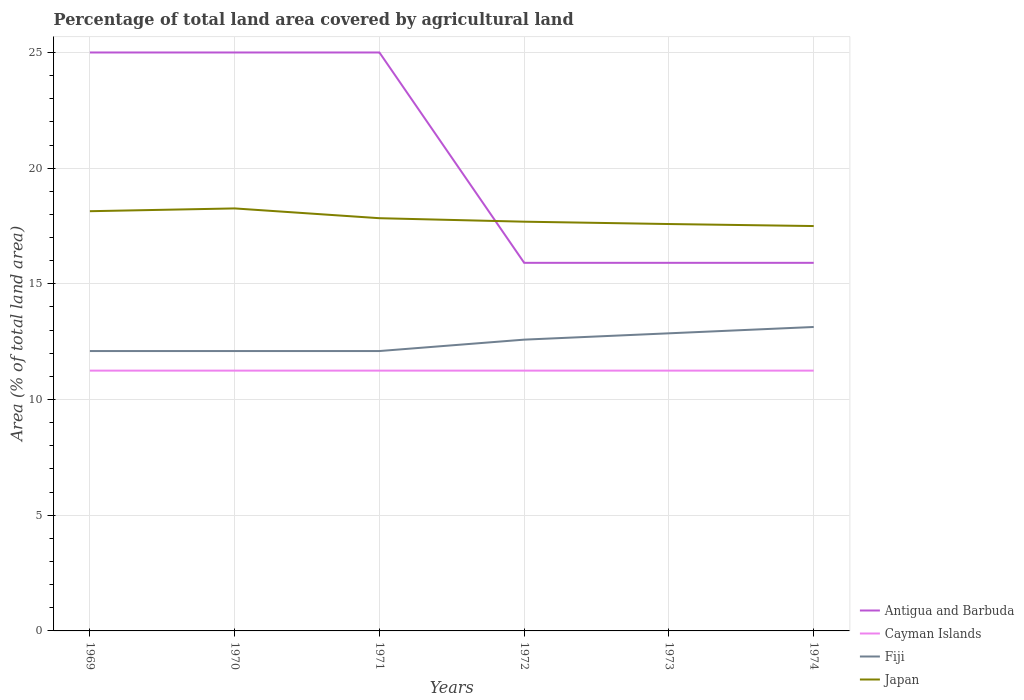Across all years, what is the maximum percentage of agricultural land in Japan?
Your answer should be compact. 17.5. What is the difference between the highest and the second highest percentage of agricultural land in Fiji?
Make the answer very short. 1.04. How many lines are there?
Provide a succinct answer. 4. How many years are there in the graph?
Your answer should be compact. 6. What is the difference between two consecutive major ticks on the Y-axis?
Make the answer very short. 5. Are the values on the major ticks of Y-axis written in scientific E-notation?
Make the answer very short. No. Where does the legend appear in the graph?
Make the answer very short. Bottom right. How are the legend labels stacked?
Keep it short and to the point. Vertical. What is the title of the graph?
Provide a succinct answer. Percentage of total land area covered by agricultural land. What is the label or title of the X-axis?
Your answer should be compact. Years. What is the label or title of the Y-axis?
Keep it short and to the point. Area (% of total land area). What is the Area (% of total land area) of Antigua and Barbuda in 1969?
Provide a succinct answer. 25. What is the Area (% of total land area) in Cayman Islands in 1969?
Make the answer very short. 11.25. What is the Area (% of total land area) in Fiji in 1969?
Your answer should be very brief. 12.1. What is the Area (% of total land area) of Japan in 1969?
Give a very brief answer. 18.14. What is the Area (% of total land area) in Antigua and Barbuda in 1970?
Your response must be concise. 25. What is the Area (% of total land area) in Cayman Islands in 1970?
Your answer should be compact. 11.25. What is the Area (% of total land area) in Fiji in 1970?
Your answer should be very brief. 12.1. What is the Area (% of total land area) in Japan in 1970?
Provide a succinct answer. 18.26. What is the Area (% of total land area) in Cayman Islands in 1971?
Offer a very short reply. 11.25. What is the Area (% of total land area) of Fiji in 1971?
Give a very brief answer. 12.1. What is the Area (% of total land area) of Japan in 1971?
Your answer should be compact. 17.84. What is the Area (% of total land area) of Antigua and Barbuda in 1972?
Give a very brief answer. 15.91. What is the Area (% of total land area) of Cayman Islands in 1972?
Keep it short and to the point. 11.25. What is the Area (% of total land area) in Fiji in 1972?
Provide a short and direct response. 12.59. What is the Area (% of total land area) of Japan in 1972?
Make the answer very short. 17.69. What is the Area (% of total land area) in Antigua and Barbuda in 1973?
Offer a terse response. 15.91. What is the Area (% of total land area) of Cayman Islands in 1973?
Offer a terse response. 11.25. What is the Area (% of total land area) in Fiji in 1973?
Your answer should be compact. 12.86. What is the Area (% of total land area) of Japan in 1973?
Offer a terse response. 17.59. What is the Area (% of total land area) in Antigua and Barbuda in 1974?
Give a very brief answer. 15.91. What is the Area (% of total land area) of Cayman Islands in 1974?
Offer a very short reply. 11.25. What is the Area (% of total land area) of Fiji in 1974?
Provide a succinct answer. 13.14. What is the Area (% of total land area) of Japan in 1974?
Your response must be concise. 17.5. Across all years, what is the maximum Area (% of total land area) of Antigua and Barbuda?
Ensure brevity in your answer.  25. Across all years, what is the maximum Area (% of total land area) in Cayman Islands?
Give a very brief answer. 11.25. Across all years, what is the maximum Area (% of total land area) of Fiji?
Provide a short and direct response. 13.14. Across all years, what is the maximum Area (% of total land area) of Japan?
Give a very brief answer. 18.26. Across all years, what is the minimum Area (% of total land area) of Antigua and Barbuda?
Offer a very short reply. 15.91. Across all years, what is the minimum Area (% of total land area) in Cayman Islands?
Provide a succinct answer. 11.25. Across all years, what is the minimum Area (% of total land area) in Fiji?
Give a very brief answer. 12.1. Across all years, what is the minimum Area (% of total land area) in Japan?
Your response must be concise. 17.5. What is the total Area (% of total land area) of Antigua and Barbuda in the graph?
Provide a short and direct response. 122.73. What is the total Area (% of total land area) in Cayman Islands in the graph?
Your response must be concise. 67.5. What is the total Area (% of total land area) in Fiji in the graph?
Offer a very short reply. 74.88. What is the total Area (% of total land area) in Japan in the graph?
Provide a succinct answer. 107.01. What is the difference between the Area (% of total land area) of Antigua and Barbuda in 1969 and that in 1970?
Keep it short and to the point. 0. What is the difference between the Area (% of total land area) of Cayman Islands in 1969 and that in 1970?
Your answer should be very brief. 0. What is the difference between the Area (% of total land area) in Fiji in 1969 and that in 1970?
Ensure brevity in your answer.  0. What is the difference between the Area (% of total land area) in Japan in 1969 and that in 1970?
Your answer should be very brief. -0.12. What is the difference between the Area (% of total land area) of Antigua and Barbuda in 1969 and that in 1971?
Keep it short and to the point. 0. What is the difference between the Area (% of total land area) in Cayman Islands in 1969 and that in 1971?
Your answer should be very brief. 0. What is the difference between the Area (% of total land area) in Fiji in 1969 and that in 1971?
Ensure brevity in your answer.  0. What is the difference between the Area (% of total land area) of Japan in 1969 and that in 1971?
Provide a succinct answer. 0.3. What is the difference between the Area (% of total land area) of Antigua and Barbuda in 1969 and that in 1972?
Your answer should be compact. 9.09. What is the difference between the Area (% of total land area) in Fiji in 1969 and that in 1972?
Your answer should be compact. -0.49. What is the difference between the Area (% of total land area) in Japan in 1969 and that in 1972?
Provide a succinct answer. 0.45. What is the difference between the Area (% of total land area) of Antigua and Barbuda in 1969 and that in 1973?
Offer a terse response. 9.09. What is the difference between the Area (% of total land area) in Cayman Islands in 1969 and that in 1973?
Your answer should be compact. 0. What is the difference between the Area (% of total land area) of Fiji in 1969 and that in 1973?
Give a very brief answer. -0.77. What is the difference between the Area (% of total land area) in Japan in 1969 and that in 1973?
Your response must be concise. 0.55. What is the difference between the Area (% of total land area) in Antigua and Barbuda in 1969 and that in 1974?
Give a very brief answer. 9.09. What is the difference between the Area (% of total land area) in Fiji in 1969 and that in 1974?
Offer a terse response. -1.04. What is the difference between the Area (% of total land area) of Japan in 1969 and that in 1974?
Provide a succinct answer. 0.64. What is the difference between the Area (% of total land area) in Antigua and Barbuda in 1970 and that in 1971?
Provide a succinct answer. 0. What is the difference between the Area (% of total land area) of Cayman Islands in 1970 and that in 1971?
Your answer should be very brief. 0. What is the difference between the Area (% of total land area) of Japan in 1970 and that in 1971?
Ensure brevity in your answer.  0.42. What is the difference between the Area (% of total land area) of Antigua and Barbuda in 1970 and that in 1972?
Keep it short and to the point. 9.09. What is the difference between the Area (% of total land area) of Fiji in 1970 and that in 1972?
Your response must be concise. -0.49. What is the difference between the Area (% of total land area) in Japan in 1970 and that in 1972?
Give a very brief answer. 0.57. What is the difference between the Area (% of total land area) in Antigua and Barbuda in 1970 and that in 1973?
Offer a very short reply. 9.09. What is the difference between the Area (% of total land area) of Cayman Islands in 1970 and that in 1973?
Offer a very short reply. 0. What is the difference between the Area (% of total land area) of Fiji in 1970 and that in 1973?
Your answer should be very brief. -0.77. What is the difference between the Area (% of total land area) of Japan in 1970 and that in 1973?
Offer a terse response. 0.67. What is the difference between the Area (% of total land area) of Antigua and Barbuda in 1970 and that in 1974?
Your response must be concise. 9.09. What is the difference between the Area (% of total land area) in Cayman Islands in 1970 and that in 1974?
Your response must be concise. 0. What is the difference between the Area (% of total land area) in Fiji in 1970 and that in 1974?
Provide a succinct answer. -1.04. What is the difference between the Area (% of total land area) of Japan in 1970 and that in 1974?
Ensure brevity in your answer.  0.76. What is the difference between the Area (% of total land area) of Antigua and Barbuda in 1971 and that in 1972?
Offer a very short reply. 9.09. What is the difference between the Area (% of total land area) in Fiji in 1971 and that in 1972?
Your response must be concise. -0.49. What is the difference between the Area (% of total land area) in Japan in 1971 and that in 1972?
Ensure brevity in your answer.  0.15. What is the difference between the Area (% of total land area) in Antigua and Barbuda in 1971 and that in 1973?
Make the answer very short. 9.09. What is the difference between the Area (% of total land area) in Fiji in 1971 and that in 1973?
Ensure brevity in your answer.  -0.77. What is the difference between the Area (% of total land area) of Japan in 1971 and that in 1973?
Keep it short and to the point. 0.25. What is the difference between the Area (% of total land area) of Antigua and Barbuda in 1971 and that in 1974?
Your answer should be compact. 9.09. What is the difference between the Area (% of total land area) in Fiji in 1971 and that in 1974?
Make the answer very short. -1.04. What is the difference between the Area (% of total land area) in Japan in 1971 and that in 1974?
Your answer should be compact. 0.34. What is the difference between the Area (% of total land area) in Antigua and Barbuda in 1972 and that in 1973?
Your response must be concise. 0. What is the difference between the Area (% of total land area) in Fiji in 1972 and that in 1973?
Your answer should be very brief. -0.27. What is the difference between the Area (% of total land area) in Japan in 1972 and that in 1973?
Offer a terse response. 0.1. What is the difference between the Area (% of total land area) in Antigua and Barbuda in 1972 and that in 1974?
Make the answer very short. 0. What is the difference between the Area (% of total land area) in Cayman Islands in 1972 and that in 1974?
Make the answer very short. 0. What is the difference between the Area (% of total land area) of Fiji in 1972 and that in 1974?
Your answer should be very brief. -0.55. What is the difference between the Area (% of total land area) in Japan in 1972 and that in 1974?
Provide a short and direct response. 0.19. What is the difference between the Area (% of total land area) of Antigua and Barbuda in 1973 and that in 1974?
Make the answer very short. 0. What is the difference between the Area (% of total land area) in Cayman Islands in 1973 and that in 1974?
Your response must be concise. 0. What is the difference between the Area (% of total land area) in Fiji in 1973 and that in 1974?
Provide a succinct answer. -0.27. What is the difference between the Area (% of total land area) in Japan in 1973 and that in 1974?
Your answer should be compact. 0.09. What is the difference between the Area (% of total land area) of Antigua and Barbuda in 1969 and the Area (% of total land area) of Cayman Islands in 1970?
Offer a very short reply. 13.75. What is the difference between the Area (% of total land area) of Antigua and Barbuda in 1969 and the Area (% of total land area) of Fiji in 1970?
Provide a succinct answer. 12.9. What is the difference between the Area (% of total land area) of Antigua and Barbuda in 1969 and the Area (% of total land area) of Japan in 1970?
Make the answer very short. 6.74. What is the difference between the Area (% of total land area) in Cayman Islands in 1969 and the Area (% of total land area) in Fiji in 1970?
Offer a very short reply. -0.85. What is the difference between the Area (% of total land area) of Cayman Islands in 1969 and the Area (% of total land area) of Japan in 1970?
Offer a terse response. -7.01. What is the difference between the Area (% of total land area) in Fiji in 1969 and the Area (% of total land area) in Japan in 1970?
Offer a very short reply. -6.16. What is the difference between the Area (% of total land area) in Antigua and Barbuda in 1969 and the Area (% of total land area) in Cayman Islands in 1971?
Make the answer very short. 13.75. What is the difference between the Area (% of total land area) in Antigua and Barbuda in 1969 and the Area (% of total land area) in Fiji in 1971?
Your answer should be very brief. 12.9. What is the difference between the Area (% of total land area) of Antigua and Barbuda in 1969 and the Area (% of total land area) of Japan in 1971?
Give a very brief answer. 7.16. What is the difference between the Area (% of total land area) in Cayman Islands in 1969 and the Area (% of total land area) in Fiji in 1971?
Provide a succinct answer. -0.85. What is the difference between the Area (% of total land area) of Cayman Islands in 1969 and the Area (% of total land area) of Japan in 1971?
Ensure brevity in your answer.  -6.59. What is the difference between the Area (% of total land area) in Fiji in 1969 and the Area (% of total land area) in Japan in 1971?
Your response must be concise. -5.74. What is the difference between the Area (% of total land area) in Antigua and Barbuda in 1969 and the Area (% of total land area) in Cayman Islands in 1972?
Offer a very short reply. 13.75. What is the difference between the Area (% of total land area) in Antigua and Barbuda in 1969 and the Area (% of total land area) in Fiji in 1972?
Provide a short and direct response. 12.41. What is the difference between the Area (% of total land area) of Antigua and Barbuda in 1969 and the Area (% of total land area) of Japan in 1972?
Your response must be concise. 7.31. What is the difference between the Area (% of total land area) in Cayman Islands in 1969 and the Area (% of total land area) in Fiji in 1972?
Give a very brief answer. -1.34. What is the difference between the Area (% of total land area) in Cayman Islands in 1969 and the Area (% of total land area) in Japan in 1972?
Ensure brevity in your answer.  -6.44. What is the difference between the Area (% of total land area) in Fiji in 1969 and the Area (% of total land area) in Japan in 1972?
Your answer should be compact. -5.59. What is the difference between the Area (% of total land area) of Antigua and Barbuda in 1969 and the Area (% of total land area) of Cayman Islands in 1973?
Make the answer very short. 13.75. What is the difference between the Area (% of total land area) of Antigua and Barbuda in 1969 and the Area (% of total land area) of Fiji in 1973?
Your answer should be compact. 12.14. What is the difference between the Area (% of total land area) in Antigua and Barbuda in 1969 and the Area (% of total land area) in Japan in 1973?
Provide a short and direct response. 7.41. What is the difference between the Area (% of total land area) in Cayman Islands in 1969 and the Area (% of total land area) in Fiji in 1973?
Offer a very short reply. -1.61. What is the difference between the Area (% of total land area) in Cayman Islands in 1969 and the Area (% of total land area) in Japan in 1973?
Your answer should be compact. -6.34. What is the difference between the Area (% of total land area) in Fiji in 1969 and the Area (% of total land area) in Japan in 1973?
Make the answer very short. -5.49. What is the difference between the Area (% of total land area) of Antigua and Barbuda in 1969 and the Area (% of total land area) of Cayman Islands in 1974?
Your answer should be compact. 13.75. What is the difference between the Area (% of total land area) of Antigua and Barbuda in 1969 and the Area (% of total land area) of Fiji in 1974?
Make the answer very short. 11.86. What is the difference between the Area (% of total land area) of Antigua and Barbuda in 1969 and the Area (% of total land area) of Japan in 1974?
Offer a terse response. 7.5. What is the difference between the Area (% of total land area) in Cayman Islands in 1969 and the Area (% of total land area) in Fiji in 1974?
Make the answer very short. -1.89. What is the difference between the Area (% of total land area) of Cayman Islands in 1969 and the Area (% of total land area) of Japan in 1974?
Give a very brief answer. -6.25. What is the difference between the Area (% of total land area) of Fiji in 1969 and the Area (% of total land area) of Japan in 1974?
Give a very brief answer. -5.4. What is the difference between the Area (% of total land area) of Antigua and Barbuda in 1970 and the Area (% of total land area) of Cayman Islands in 1971?
Your answer should be very brief. 13.75. What is the difference between the Area (% of total land area) in Antigua and Barbuda in 1970 and the Area (% of total land area) in Fiji in 1971?
Your response must be concise. 12.9. What is the difference between the Area (% of total land area) of Antigua and Barbuda in 1970 and the Area (% of total land area) of Japan in 1971?
Keep it short and to the point. 7.16. What is the difference between the Area (% of total land area) of Cayman Islands in 1970 and the Area (% of total land area) of Fiji in 1971?
Provide a short and direct response. -0.85. What is the difference between the Area (% of total land area) of Cayman Islands in 1970 and the Area (% of total land area) of Japan in 1971?
Your answer should be very brief. -6.59. What is the difference between the Area (% of total land area) of Fiji in 1970 and the Area (% of total land area) of Japan in 1971?
Provide a short and direct response. -5.74. What is the difference between the Area (% of total land area) of Antigua and Barbuda in 1970 and the Area (% of total land area) of Cayman Islands in 1972?
Offer a very short reply. 13.75. What is the difference between the Area (% of total land area) in Antigua and Barbuda in 1970 and the Area (% of total land area) in Fiji in 1972?
Your answer should be compact. 12.41. What is the difference between the Area (% of total land area) in Antigua and Barbuda in 1970 and the Area (% of total land area) in Japan in 1972?
Keep it short and to the point. 7.31. What is the difference between the Area (% of total land area) of Cayman Islands in 1970 and the Area (% of total land area) of Fiji in 1972?
Offer a terse response. -1.34. What is the difference between the Area (% of total land area) in Cayman Islands in 1970 and the Area (% of total land area) in Japan in 1972?
Give a very brief answer. -6.44. What is the difference between the Area (% of total land area) of Fiji in 1970 and the Area (% of total land area) of Japan in 1972?
Keep it short and to the point. -5.59. What is the difference between the Area (% of total land area) in Antigua and Barbuda in 1970 and the Area (% of total land area) in Cayman Islands in 1973?
Keep it short and to the point. 13.75. What is the difference between the Area (% of total land area) in Antigua and Barbuda in 1970 and the Area (% of total land area) in Fiji in 1973?
Your answer should be very brief. 12.14. What is the difference between the Area (% of total land area) of Antigua and Barbuda in 1970 and the Area (% of total land area) of Japan in 1973?
Give a very brief answer. 7.41. What is the difference between the Area (% of total land area) in Cayman Islands in 1970 and the Area (% of total land area) in Fiji in 1973?
Your response must be concise. -1.61. What is the difference between the Area (% of total land area) of Cayman Islands in 1970 and the Area (% of total land area) of Japan in 1973?
Provide a succinct answer. -6.34. What is the difference between the Area (% of total land area) in Fiji in 1970 and the Area (% of total land area) in Japan in 1973?
Your response must be concise. -5.49. What is the difference between the Area (% of total land area) of Antigua and Barbuda in 1970 and the Area (% of total land area) of Cayman Islands in 1974?
Ensure brevity in your answer.  13.75. What is the difference between the Area (% of total land area) in Antigua and Barbuda in 1970 and the Area (% of total land area) in Fiji in 1974?
Your answer should be compact. 11.86. What is the difference between the Area (% of total land area) in Antigua and Barbuda in 1970 and the Area (% of total land area) in Japan in 1974?
Provide a succinct answer. 7.5. What is the difference between the Area (% of total land area) of Cayman Islands in 1970 and the Area (% of total land area) of Fiji in 1974?
Offer a very short reply. -1.89. What is the difference between the Area (% of total land area) of Cayman Islands in 1970 and the Area (% of total land area) of Japan in 1974?
Offer a terse response. -6.25. What is the difference between the Area (% of total land area) of Fiji in 1970 and the Area (% of total land area) of Japan in 1974?
Keep it short and to the point. -5.4. What is the difference between the Area (% of total land area) of Antigua and Barbuda in 1971 and the Area (% of total land area) of Cayman Islands in 1972?
Offer a terse response. 13.75. What is the difference between the Area (% of total land area) in Antigua and Barbuda in 1971 and the Area (% of total land area) in Fiji in 1972?
Keep it short and to the point. 12.41. What is the difference between the Area (% of total land area) in Antigua and Barbuda in 1971 and the Area (% of total land area) in Japan in 1972?
Make the answer very short. 7.31. What is the difference between the Area (% of total land area) of Cayman Islands in 1971 and the Area (% of total land area) of Fiji in 1972?
Provide a short and direct response. -1.34. What is the difference between the Area (% of total land area) in Cayman Islands in 1971 and the Area (% of total land area) in Japan in 1972?
Your answer should be compact. -6.44. What is the difference between the Area (% of total land area) of Fiji in 1971 and the Area (% of total land area) of Japan in 1972?
Keep it short and to the point. -5.59. What is the difference between the Area (% of total land area) of Antigua and Barbuda in 1971 and the Area (% of total land area) of Cayman Islands in 1973?
Your answer should be compact. 13.75. What is the difference between the Area (% of total land area) of Antigua and Barbuda in 1971 and the Area (% of total land area) of Fiji in 1973?
Keep it short and to the point. 12.14. What is the difference between the Area (% of total land area) in Antigua and Barbuda in 1971 and the Area (% of total land area) in Japan in 1973?
Provide a short and direct response. 7.41. What is the difference between the Area (% of total land area) of Cayman Islands in 1971 and the Area (% of total land area) of Fiji in 1973?
Keep it short and to the point. -1.61. What is the difference between the Area (% of total land area) in Cayman Islands in 1971 and the Area (% of total land area) in Japan in 1973?
Offer a terse response. -6.34. What is the difference between the Area (% of total land area) in Fiji in 1971 and the Area (% of total land area) in Japan in 1973?
Provide a succinct answer. -5.49. What is the difference between the Area (% of total land area) in Antigua and Barbuda in 1971 and the Area (% of total land area) in Cayman Islands in 1974?
Provide a short and direct response. 13.75. What is the difference between the Area (% of total land area) of Antigua and Barbuda in 1971 and the Area (% of total land area) of Fiji in 1974?
Provide a short and direct response. 11.86. What is the difference between the Area (% of total land area) in Antigua and Barbuda in 1971 and the Area (% of total land area) in Japan in 1974?
Offer a terse response. 7.5. What is the difference between the Area (% of total land area) of Cayman Islands in 1971 and the Area (% of total land area) of Fiji in 1974?
Provide a short and direct response. -1.89. What is the difference between the Area (% of total land area) in Cayman Islands in 1971 and the Area (% of total land area) in Japan in 1974?
Your response must be concise. -6.25. What is the difference between the Area (% of total land area) of Fiji in 1971 and the Area (% of total land area) of Japan in 1974?
Your answer should be very brief. -5.4. What is the difference between the Area (% of total land area) in Antigua and Barbuda in 1972 and the Area (% of total land area) in Cayman Islands in 1973?
Offer a terse response. 4.66. What is the difference between the Area (% of total land area) of Antigua and Barbuda in 1972 and the Area (% of total land area) of Fiji in 1973?
Keep it short and to the point. 3.05. What is the difference between the Area (% of total land area) of Antigua and Barbuda in 1972 and the Area (% of total land area) of Japan in 1973?
Your response must be concise. -1.68. What is the difference between the Area (% of total land area) of Cayman Islands in 1972 and the Area (% of total land area) of Fiji in 1973?
Your response must be concise. -1.61. What is the difference between the Area (% of total land area) of Cayman Islands in 1972 and the Area (% of total land area) of Japan in 1973?
Your answer should be very brief. -6.34. What is the difference between the Area (% of total land area) in Fiji in 1972 and the Area (% of total land area) in Japan in 1973?
Make the answer very short. -5. What is the difference between the Area (% of total land area) in Antigua and Barbuda in 1972 and the Area (% of total land area) in Cayman Islands in 1974?
Offer a terse response. 4.66. What is the difference between the Area (% of total land area) in Antigua and Barbuda in 1972 and the Area (% of total land area) in Fiji in 1974?
Provide a short and direct response. 2.77. What is the difference between the Area (% of total land area) in Antigua and Barbuda in 1972 and the Area (% of total land area) in Japan in 1974?
Make the answer very short. -1.59. What is the difference between the Area (% of total land area) in Cayman Islands in 1972 and the Area (% of total land area) in Fiji in 1974?
Your answer should be very brief. -1.89. What is the difference between the Area (% of total land area) of Cayman Islands in 1972 and the Area (% of total land area) of Japan in 1974?
Your answer should be very brief. -6.25. What is the difference between the Area (% of total land area) of Fiji in 1972 and the Area (% of total land area) of Japan in 1974?
Provide a succinct answer. -4.91. What is the difference between the Area (% of total land area) of Antigua and Barbuda in 1973 and the Area (% of total land area) of Cayman Islands in 1974?
Provide a succinct answer. 4.66. What is the difference between the Area (% of total land area) in Antigua and Barbuda in 1973 and the Area (% of total land area) in Fiji in 1974?
Your answer should be very brief. 2.77. What is the difference between the Area (% of total land area) in Antigua and Barbuda in 1973 and the Area (% of total land area) in Japan in 1974?
Offer a terse response. -1.59. What is the difference between the Area (% of total land area) in Cayman Islands in 1973 and the Area (% of total land area) in Fiji in 1974?
Provide a succinct answer. -1.89. What is the difference between the Area (% of total land area) of Cayman Islands in 1973 and the Area (% of total land area) of Japan in 1974?
Offer a terse response. -6.25. What is the difference between the Area (% of total land area) in Fiji in 1973 and the Area (% of total land area) in Japan in 1974?
Your response must be concise. -4.64. What is the average Area (% of total land area) of Antigua and Barbuda per year?
Provide a succinct answer. 20.45. What is the average Area (% of total land area) in Cayman Islands per year?
Your answer should be very brief. 11.25. What is the average Area (% of total land area) of Fiji per year?
Offer a very short reply. 12.48. What is the average Area (% of total land area) in Japan per year?
Offer a very short reply. 17.83. In the year 1969, what is the difference between the Area (% of total land area) in Antigua and Barbuda and Area (% of total land area) in Cayman Islands?
Make the answer very short. 13.75. In the year 1969, what is the difference between the Area (% of total land area) of Antigua and Barbuda and Area (% of total land area) of Fiji?
Your answer should be very brief. 12.9. In the year 1969, what is the difference between the Area (% of total land area) of Antigua and Barbuda and Area (% of total land area) of Japan?
Your answer should be compact. 6.86. In the year 1969, what is the difference between the Area (% of total land area) of Cayman Islands and Area (% of total land area) of Fiji?
Your response must be concise. -0.85. In the year 1969, what is the difference between the Area (% of total land area) in Cayman Islands and Area (% of total land area) in Japan?
Your answer should be very brief. -6.89. In the year 1969, what is the difference between the Area (% of total land area) of Fiji and Area (% of total land area) of Japan?
Offer a terse response. -6.04. In the year 1970, what is the difference between the Area (% of total land area) in Antigua and Barbuda and Area (% of total land area) in Cayman Islands?
Provide a succinct answer. 13.75. In the year 1970, what is the difference between the Area (% of total land area) of Antigua and Barbuda and Area (% of total land area) of Fiji?
Your response must be concise. 12.9. In the year 1970, what is the difference between the Area (% of total land area) of Antigua and Barbuda and Area (% of total land area) of Japan?
Make the answer very short. 6.74. In the year 1970, what is the difference between the Area (% of total land area) in Cayman Islands and Area (% of total land area) in Fiji?
Keep it short and to the point. -0.85. In the year 1970, what is the difference between the Area (% of total land area) in Cayman Islands and Area (% of total land area) in Japan?
Offer a very short reply. -7.01. In the year 1970, what is the difference between the Area (% of total land area) of Fiji and Area (% of total land area) of Japan?
Offer a terse response. -6.16. In the year 1971, what is the difference between the Area (% of total land area) in Antigua and Barbuda and Area (% of total land area) in Cayman Islands?
Make the answer very short. 13.75. In the year 1971, what is the difference between the Area (% of total land area) of Antigua and Barbuda and Area (% of total land area) of Fiji?
Make the answer very short. 12.9. In the year 1971, what is the difference between the Area (% of total land area) in Antigua and Barbuda and Area (% of total land area) in Japan?
Keep it short and to the point. 7.16. In the year 1971, what is the difference between the Area (% of total land area) of Cayman Islands and Area (% of total land area) of Fiji?
Give a very brief answer. -0.85. In the year 1971, what is the difference between the Area (% of total land area) of Cayman Islands and Area (% of total land area) of Japan?
Provide a short and direct response. -6.59. In the year 1971, what is the difference between the Area (% of total land area) of Fiji and Area (% of total land area) of Japan?
Provide a short and direct response. -5.74. In the year 1972, what is the difference between the Area (% of total land area) of Antigua and Barbuda and Area (% of total land area) of Cayman Islands?
Offer a very short reply. 4.66. In the year 1972, what is the difference between the Area (% of total land area) in Antigua and Barbuda and Area (% of total land area) in Fiji?
Keep it short and to the point. 3.32. In the year 1972, what is the difference between the Area (% of total land area) in Antigua and Barbuda and Area (% of total land area) in Japan?
Your response must be concise. -1.78. In the year 1972, what is the difference between the Area (% of total land area) of Cayman Islands and Area (% of total land area) of Fiji?
Ensure brevity in your answer.  -1.34. In the year 1972, what is the difference between the Area (% of total land area) in Cayman Islands and Area (% of total land area) in Japan?
Make the answer very short. -6.44. In the year 1972, what is the difference between the Area (% of total land area) of Fiji and Area (% of total land area) of Japan?
Offer a terse response. -5.1. In the year 1973, what is the difference between the Area (% of total land area) of Antigua and Barbuda and Area (% of total land area) of Cayman Islands?
Make the answer very short. 4.66. In the year 1973, what is the difference between the Area (% of total land area) in Antigua and Barbuda and Area (% of total land area) in Fiji?
Your answer should be very brief. 3.05. In the year 1973, what is the difference between the Area (% of total land area) of Antigua and Barbuda and Area (% of total land area) of Japan?
Offer a terse response. -1.68. In the year 1973, what is the difference between the Area (% of total land area) in Cayman Islands and Area (% of total land area) in Fiji?
Give a very brief answer. -1.61. In the year 1973, what is the difference between the Area (% of total land area) in Cayman Islands and Area (% of total land area) in Japan?
Make the answer very short. -6.34. In the year 1973, what is the difference between the Area (% of total land area) of Fiji and Area (% of total land area) of Japan?
Your answer should be compact. -4.72. In the year 1974, what is the difference between the Area (% of total land area) of Antigua and Barbuda and Area (% of total land area) of Cayman Islands?
Offer a very short reply. 4.66. In the year 1974, what is the difference between the Area (% of total land area) in Antigua and Barbuda and Area (% of total land area) in Fiji?
Your answer should be compact. 2.77. In the year 1974, what is the difference between the Area (% of total land area) in Antigua and Barbuda and Area (% of total land area) in Japan?
Provide a succinct answer. -1.59. In the year 1974, what is the difference between the Area (% of total land area) in Cayman Islands and Area (% of total land area) in Fiji?
Your answer should be very brief. -1.89. In the year 1974, what is the difference between the Area (% of total land area) of Cayman Islands and Area (% of total land area) of Japan?
Give a very brief answer. -6.25. In the year 1974, what is the difference between the Area (% of total land area) of Fiji and Area (% of total land area) of Japan?
Give a very brief answer. -4.36. What is the ratio of the Area (% of total land area) in Antigua and Barbuda in 1969 to that in 1970?
Give a very brief answer. 1. What is the ratio of the Area (% of total land area) of Cayman Islands in 1969 to that in 1970?
Your answer should be compact. 1. What is the ratio of the Area (% of total land area) of Fiji in 1969 to that in 1971?
Offer a terse response. 1. What is the ratio of the Area (% of total land area) in Japan in 1969 to that in 1971?
Offer a terse response. 1.02. What is the ratio of the Area (% of total land area) in Antigua and Barbuda in 1969 to that in 1972?
Provide a succinct answer. 1.57. What is the ratio of the Area (% of total land area) in Fiji in 1969 to that in 1972?
Offer a terse response. 0.96. What is the ratio of the Area (% of total land area) of Japan in 1969 to that in 1972?
Ensure brevity in your answer.  1.03. What is the ratio of the Area (% of total land area) of Antigua and Barbuda in 1969 to that in 1973?
Provide a succinct answer. 1.57. What is the ratio of the Area (% of total land area) in Fiji in 1969 to that in 1973?
Your answer should be compact. 0.94. What is the ratio of the Area (% of total land area) in Japan in 1969 to that in 1973?
Offer a terse response. 1.03. What is the ratio of the Area (% of total land area) of Antigua and Barbuda in 1969 to that in 1974?
Offer a very short reply. 1.57. What is the ratio of the Area (% of total land area) of Fiji in 1969 to that in 1974?
Keep it short and to the point. 0.92. What is the ratio of the Area (% of total land area) in Japan in 1969 to that in 1974?
Give a very brief answer. 1.04. What is the ratio of the Area (% of total land area) of Antigua and Barbuda in 1970 to that in 1971?
Offer a terse response. 1. What is the ratio of the Area (% of total land area) in Cayman Islands in 1970 to that in 1971?
Offer a terse response. 1. What is the ratio of the Area (% of total land area) of Fiji in 1970 to that in 1971?
Offer a very short reply. 1. What is the ratio of the Area (% of total land area) in Japan in 1970 to that in 1971?
Offer a terse response. 1.02. What is the ratio of the Area (% of total land area) in Antigua and Barbuda in 1970 to that in 1972?
Your answer should be compact. 1.57. What is the ratio of the Area (% of total land area) in Fiji in 1970 to that in 1972?
Provide a short and direct response. 0.96. What is the ratio of the Area (% of total land area) in Japan in 1970 to that in 1972?
Your answer should be compact. 1.03. What is the ratio of the Area (% of total land area) of Antigua and Barbuda in 1970 to that in 1973?
Your answer should be very brief. 1.57. What is the ratio of the Area (% of total land area) in Fiji in 1970 to that in 1973?
Offer a terse response. 0.94. What is the ratio of the Area (% of total land area) of Japan in 1970 to that in 1973?
Make the answer very short. 1.04. What is the ratio of the Area (% of total land area) of Antigua and Barbuda in 1970 to that in 1974?
Make the answer very short. 1.57. What is the ratio of the Area (% of total land area) of Cayman Islands in 1970 to that in 1974?
Provide a succinct answer. 1. What is the ratio of the Area (% of total land area) of Fiji in 1970 to that in 1974?
Your answer should be compact. 0.92. What is the ratio of the Area (% of total land area) in Japan in 1970 to that in 1974?
Your response must be concise. 1.04. What is the ratio of the Area (% of total land area) in Antigua and Barbuda in 1971 to that in 1972?
Offer a terse response. 1.57. What is the ratio of the Area (% of total land area) of Fiji in 1971 to that in 1972?
Offer a very short reply. 0.96. What is the ratio of the Area (% of total land area) of Japan in 1971 to that in 1972?
Offer a terse response. 1.01. What is the ratio of the Area (% of total land area) in Antigua and Barbuda in 1971 to that in 1973?
Offer a terse response. 1.57. What is the ratio of the Area (% of total land area) in Cayman Islands in 1971 to that in 1973?
Your answer should be compact. 1. What is the ratio of the Area (% of total land area) of Fiji in 1971 to that in 1973?
Your answer should be compact. 0.94. What is the ratio of the Area (% of total land area) in Japan in 1971 to that in 1973?
Ensure brevity in your answer.  1.01. What is the ratio of the Area (% of total land area) in Antigua and Barbuda in 1971 to that in 1974?
Provide a short and direct response. 1.57. What is the ratio of the Area (% of total land area) in Fiji in 1971 to that in 1974?
Give a very brief answer. 0.92. What is the ratio of the Area (% of total land area) in Japan in 1971 to that in 1974?
Offer a terse response. 1.02. What is the ratio of the Area (% of total land area) of Cayman Islands in 1972 to that in 1973?
Give a very brief answer. 1. What is the ratio of the Area (% of total land area) in Fiji in 1972 to that in 1973?
Provide a succinct answer. 0.98. What is the ratio of the Area (% of total land area) of Antigua and Barbuda in 1972 to that in 1974?
Offer a terse response. 1. What is the ratio of the Area (% of total land area) in Cayman Islands in 1972 to that in 1974?
Provide a short and direct response. 1. What is the ratio of the Area (% of total land area) of Japan in 1972 to that in 1974?
Provide a succinct answer. 1.01. What is the ratio of the Area (% of total land area) in Antigua and Barbuda in 1973 to that in 1974?
Make the answer very short. 1. What is the ratio of the Area (% of total land area) of Fiji in 1973 to that in 1974?
Your response must be concise. 0.98. What is the ratio of the Area (% of total land area) of Japan in 1973 to that in 1974?
Provide a short and direct response. 1. What is the difference between the highest and the second highest Area (% of total land area) in Cayman Islands?
Give a very brief answer. 0. What is the difference between the highest and the second highest Area (% of total land area) in Fiji?
Provide a short and direct response. 0.27. What is the difference between the highest and the second highest Area (% of total land area) of Japan?
Give a very brief answer. 0.12. What is the difference between the highest and the lowest Area (% of total land area) of Antigua and Barbuda?
Keep it short and to the point. 9.09. What is the difference between the highest and the lowest Area (% of total land area) in Japan?
Your answer should be very brief. 0.76. 